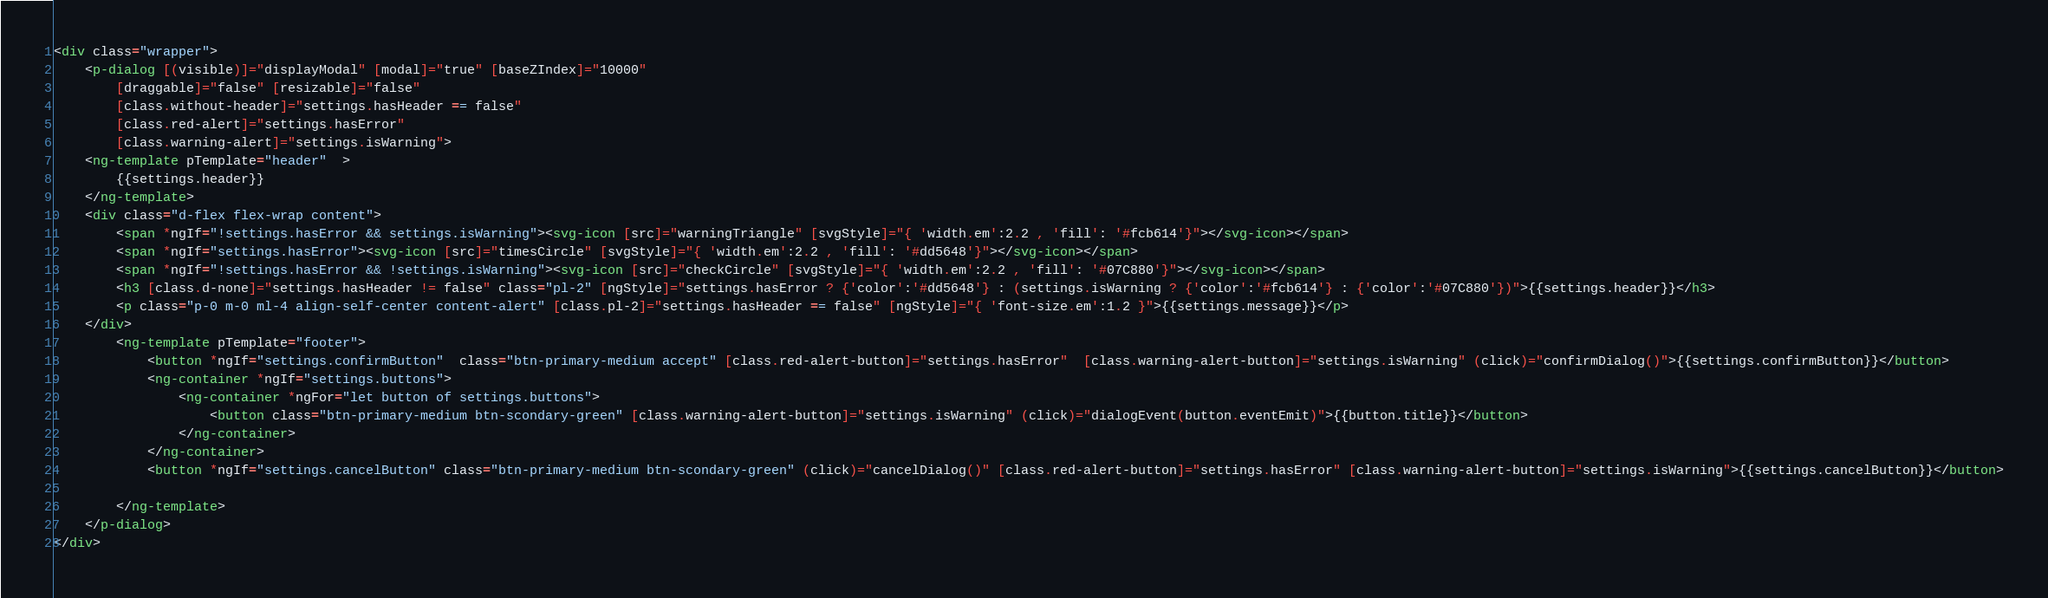<code> <loc_0><loc_0><loc_500><loc_500><_HTML_><div class="wrapper">
    <p-dialog [(visible)]="displayModal" [modal]="true" [baseZIndex]="10000"
        [draggable]="false" [resizable]="false"
        [class.without-header]="settings.hasHeader == false"
        [class.red-alert]="settings.hasError"
        [class.warning-alert]="settings.isWarning">
    <ng-template pTemplate="header"  >
        {{settings.header}}
    </ng-template>
    <div class="d-flex flex-wrap content">
        <span *ngIf="!settings.hasError && settings.isWarning"><svg-icon [src]="warningTriangle" [svgStyle]="{ 'width.em':2.2 , 'fill': '#fcb614'}"></svg-icon></span>
        <span *ngIf="settings.hasError"><svg-icon [src]="timesCircle" [svgStyle]="{ 'width.em':2.2 , 'fill': '#dd5648'}"></svg-icon></span>
        <span *ngIf="!settings.hasError && !settings.isWarning"><svg-icon [src]="checkCircle" [svgStyle]="{ 'width.em':2.2 , 'fill': '#07C880'}"></svg-icon></span>
        <h3 [class.d-none]="settings.hasHeader != false" class="pl-2" [ngStyle]="settings.hasError ? {'color':'#dd5648'} : (settings.isWarning ? {'color':'#fcb614'} : {'color':'#07C880'})">{{settings.header}}</h3>
        <p class="p-0 m-0 ml-4 align-self-center content-alert" [class.pl-2]="settings.hasHeader == false" [ngStyle]="{ 'font-size.em':1.2 }">{{settings.message}}</p>
    </div>
        <ng-template pTemplate="footer">
            <button *ngIf="settings.confirmButton"  class="btn-primary-medium accept" [class.red-alert-button]="settings.hasError"  [class.warning-alert-button]="settings.isWarning" (click)="confirmDialog()">{{settings.confirmButton}}</button>
            <ng-container *ngIf="settings.buttons">
                <ng-container *ngFor="let button of settings.buttons">
                    <button class="btn-primary-medium btn-scondary-green" [class.warning-alert-button]="settings.isWarning" (click)="dialogEvent(button.eventEmit)">{{button.title}}</button>
                </ng-container>
            </ng-container>
            <button *ngIf="settings.cancelButton" class="btn-primary-medium btn-scondary-green" (click)="cancelDialog()" [class.red-alert-button]="settings.hasError" [class.warning-alert-button]="settings.isWarning">{{settings.cancelButton}}</button>
            
        </ng-template>
    </p-dialog>
</div>



</code> 